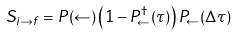Convert formula to latex. <formula><loc_0><loc_0><loc_500><loc_500>S _ { i \to f } = P ( \leftarrow ) \left ( 1 - P _ { \leftarrow } ^ { \dagger } ( \tau ) \right ) P _ { \leftarrow } ( \Delta \tau )</formula> 